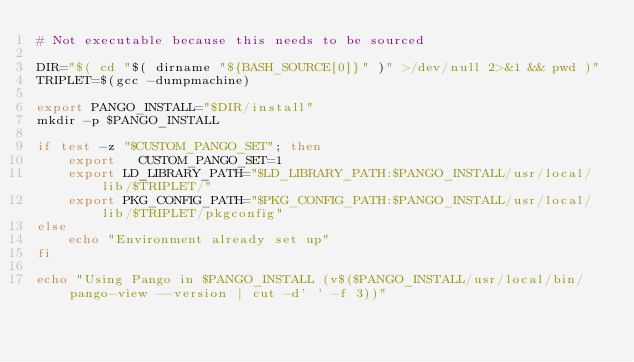<code> <loc_0><loc_0><loc_500><loc_500><_Bash_># Not executable because this needs to be sourced

DIR="$( cd "$( dirname "${BASH_SOURCE[0]}" )" >/dev/null 2>&1 && pwd )"
TRIPLET=$(gcc -dumpmachine)

export PANGO_INSTALL="$DIR/install"
mkdir -p $PANGO_INSTALL

if test -z "$CUSTOM_PANGO_SET"; then
    export   CUSTOM_PANGO_SET=1
    export LD_LIBRARY_PATH="$LD_LIBRARY_PATH:$PANGO_INSTALL/usr/local/lib/$TRIPLET/"
    export PKG_CONFIG_PATH="$PKG_CONFIG_PATH:$PANGO_INSTALL/usr/local/lib/$TRIPLET/pkgconfig"
else
    echo "Environment already set up"
fi

echo "Using Pango in $PANGO_INSTALL (v$($PANGO_INSTALL/usr/local/bin/pango-view --version | cut -d' ' -f 3))"
</code> 